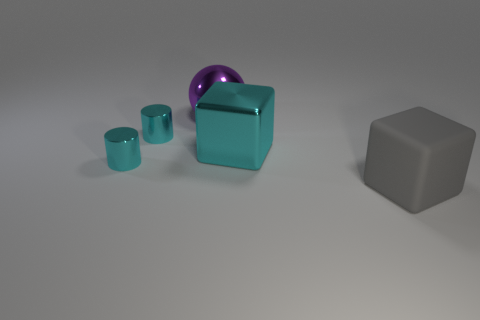What could be the relationship between these objects? Though inanimate, these objects could be perceived as part of a cohesive collection, perhaps part of a set of designer items or an abstract art installation. Alternatively, they may represent different geometric shapes used for an instructional purpose, such as teaching about volume and spatial relationships. Do these objects appear functional or purely decorative? These objects seem to lean towards the decorative side, given their placement and the simple, clean lines. They lack any apparent mechanisms or features that suggest utility, leading one to surmise they're designed with aesthetics or educational display in mind. 